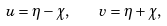<formula> <loc_0><loc_0><loc_500><loc_500>u = \eta - \chi , \quad v = \eta + \chi ,</formula> 